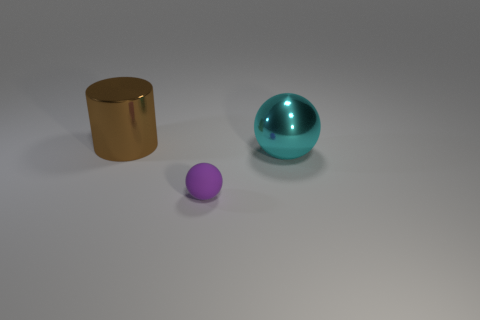Are there any other things that have the same material as the tiny purple ball?
Make the answer very short. No. There is a small purple matte object that is on the right side of the brown thing; are there any cyan metal spheres on the left side of it?
Give a very brief answer. No. There is a tiny purple object; what number of metal things are behind it?
Offer a terse response. 2. There is a large shiny thing that is the same shape as the rubber object; what color is it?
Your response must be concise. Cyan. Are the large thing that is on the right side of the tiny matte thing and the tiny sphere that is in front of the big brown cylinder made of the same material?
Your answer should be compact. No. There is a metallic ball; is its color the same as the object that is left of the small object?
Your answer should be very brief. No. There is a thing that is both in front of the brown metallic object and behind the small purple sphere; what is its shape?
Keep it short and to the point. Sphere. How many big brown metallic blocks are there?
Offer a very short reply. 0. What size is the cyan object that is the same shape as the small purple thing?
Your answer should be very brief. Large. There is a metal object that is to the right of the tiny purple thing; is its shape the same as the large brown thing?
Your response must be concise. No. 